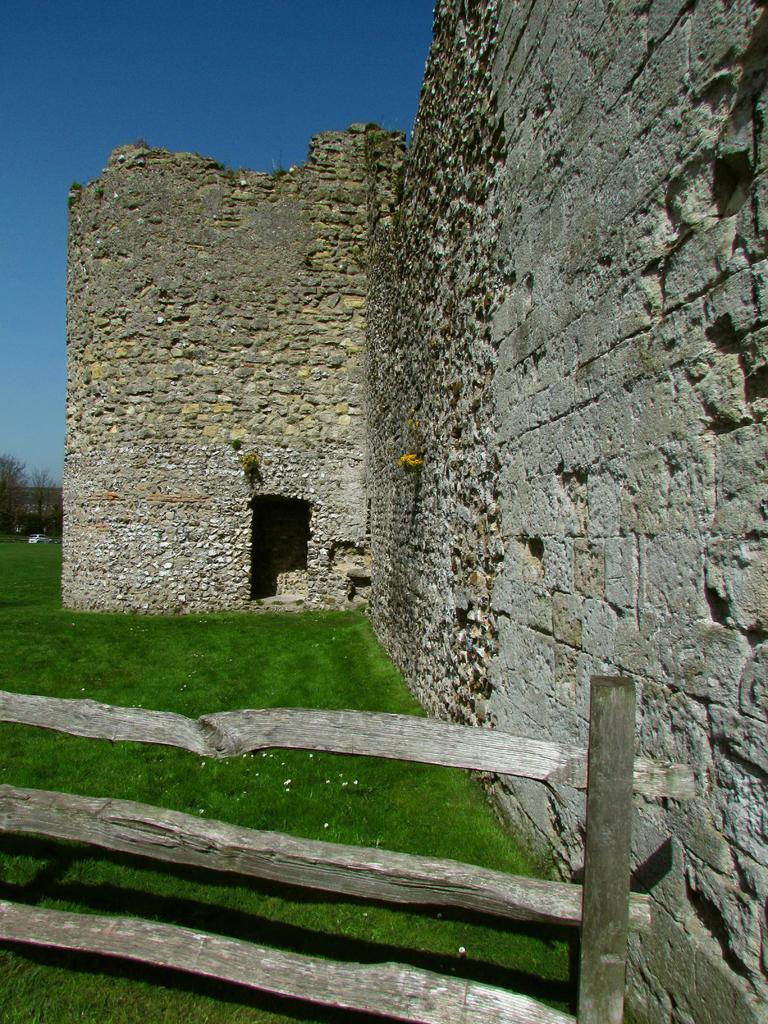What can be seen at the bottom of the image? There is a boundary at the bottom side of the image. What type of landscape is in the center of the image? There is a grassland in the center of the image. What structure is located on the right side of the image? There is a wall on the right side of the image. What is the taste of the zephyr in the image? There is no mention of a zephyr in the image, and therefore no taste can be attributed to it. How many carriages are present in the image? There is no mention of a carriage in the image. 